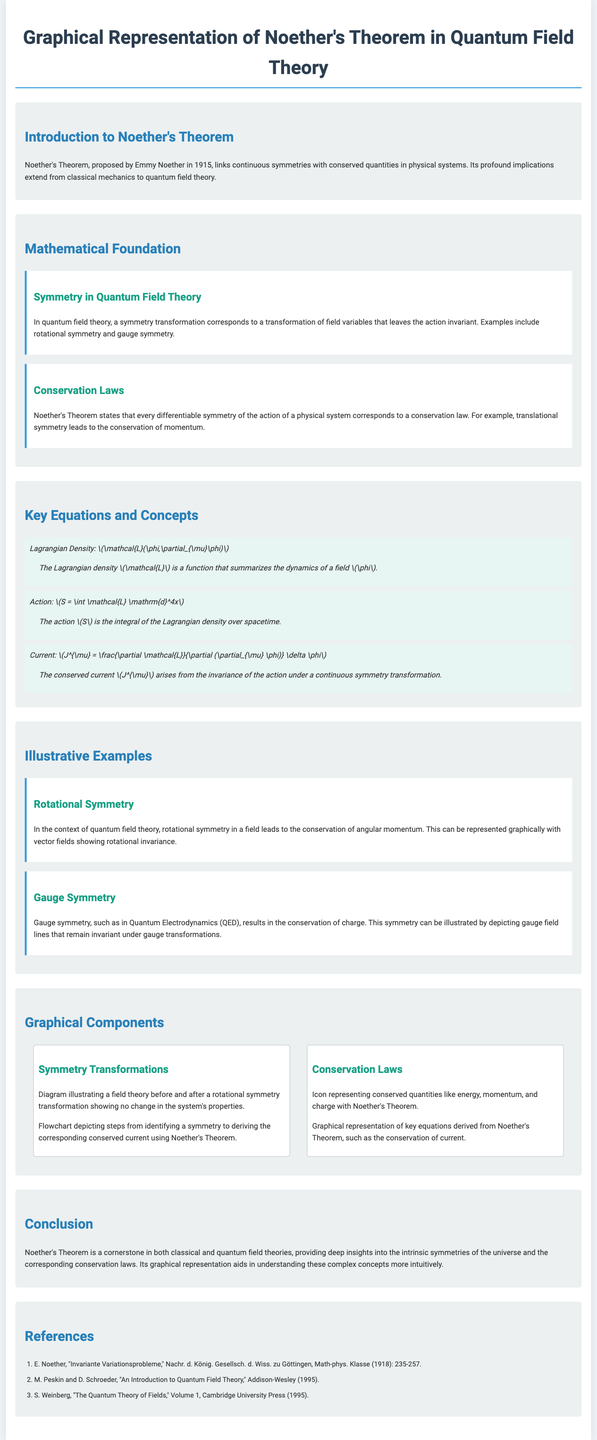What is Noether's Theorem? Noether's Theorem links continuous symmetries with conserved quantities in physical systems.
Answer: links continuous symmetries with conserved quantities Who proposed Noether's Theorem? The document states that Noether's Theorem was proposed by Emmy Noether.
Answer: Emmy Noether What does translational symmetry lead to? The document mentions that translational symmetry leads to the conservation of momentum.
Answer: conservation of momentum What is the Lagrangian Density symbol? The symbol for Lagrangian Density given in the document is \(\mathcal{L}\).
Answer: \(\mathcal{L}\) What type of symmetry does Quantum Electrodynamics exhibit? The document mentions that Quantum Electrodynamics exhibits gauge symmetry.
Answer: gauge symmetry How many references are cited in the document? The number of references listed in the document is three.
Answer: three What are conserved quantities represented in the graphical components? The document lists conserved quantities like energy, momentum, and charge.
Answer: energy, momentum, and charge What does the conserved current \(J^{\mu}\) arise from? According to the document, the conserved current \(J^{\mu}\) arises from the invariance of the action under a continuous symmetry transformation.
Answer: invariance of the action under a continuous symmetry transformation What is the significance of Noether's Theorem mentioned in the conclusion? The conclusion states that Noether's Theorem provides deep insights into intrinsic symmetries and conservation laws.
Answer: intrinsic symmetries and conservation laws 